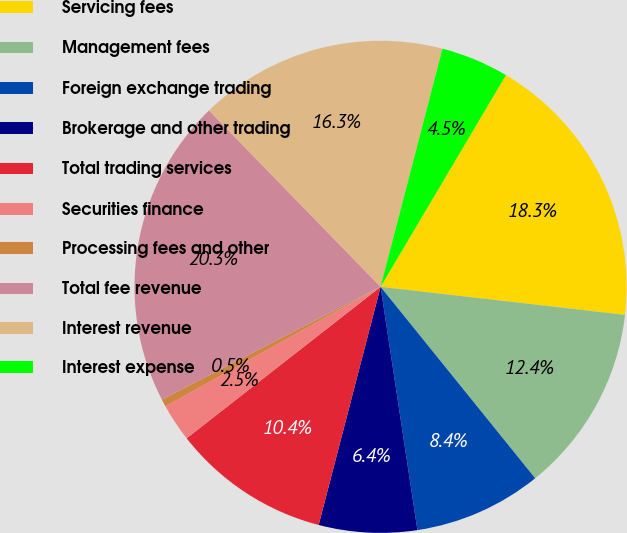<chart> <loc_0><loc_0><loc_500><loc_500><pie_chart><fcel>Servicing fees<fcel>Management fees<fcel>Foreign exchange trading<fcel>Brokerage and other trading<fcel>Total trading services<fcel>Securities finance<fcel>Processing fees and other<fcel>Total fee revenue<fcel>Interest revenue<fcel>Interest expense<nl><fcel>18.31%<fcel>12.37%<fcel>8.42%<fcel>6.44%<fcel>10.4%<fcel>2.48%<fcel>0.5%<fcel>20.29%<fcel>16.33%<fcel>4.46%<nl></chart> 